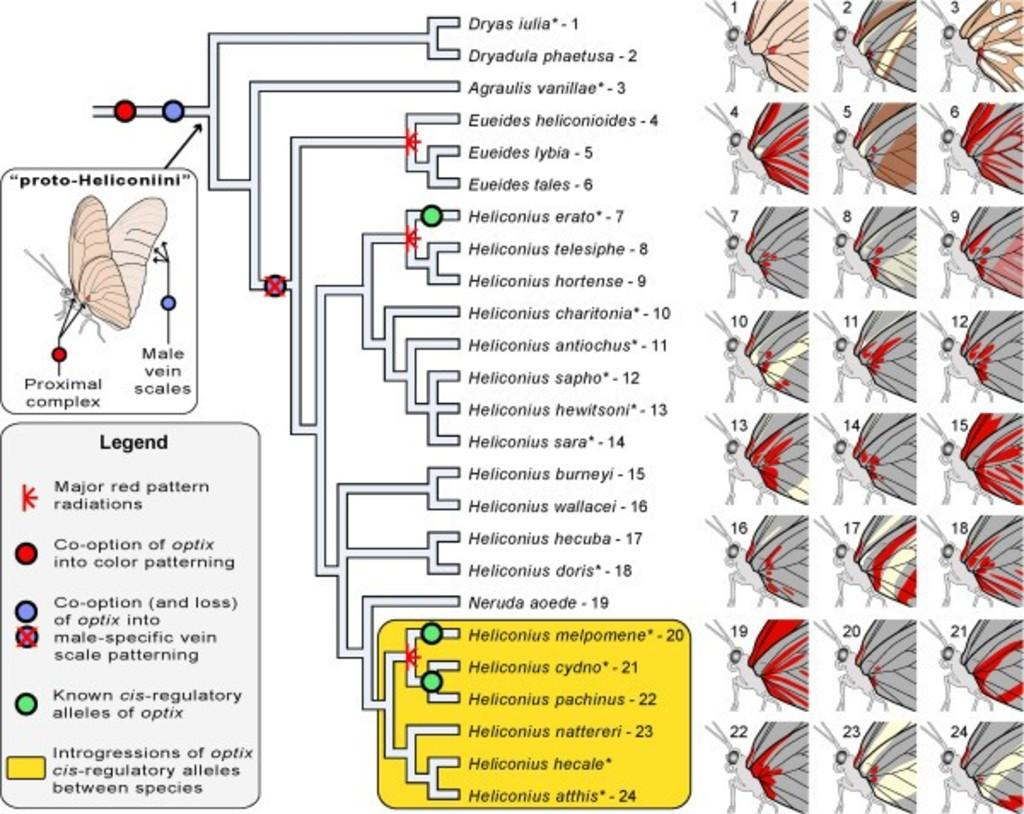What is the main subject of the image? The main subject of the image is a flowchart. What can be found within the flowchart? The flowchart contains text. How many socks are hanging on the line in the image? There are no socks present in the image; it features a flowchart with text. What type of bears can be seen interacting with the flowchart in the image? There are no bears present in the image; it features a flowchart with text. 